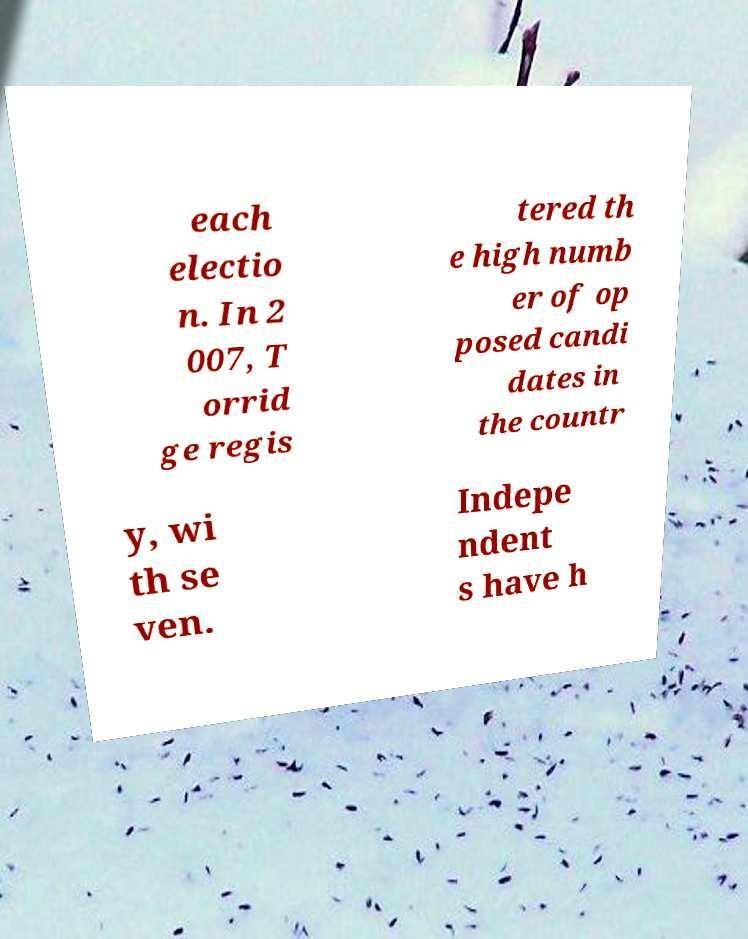Could you extract and type out the text from this image? each electio n. In 2 007, T orrid ge regis tered th e high numb er of op posed candi dates in the countr y, wi th se ven. Indepe ndent s have h 